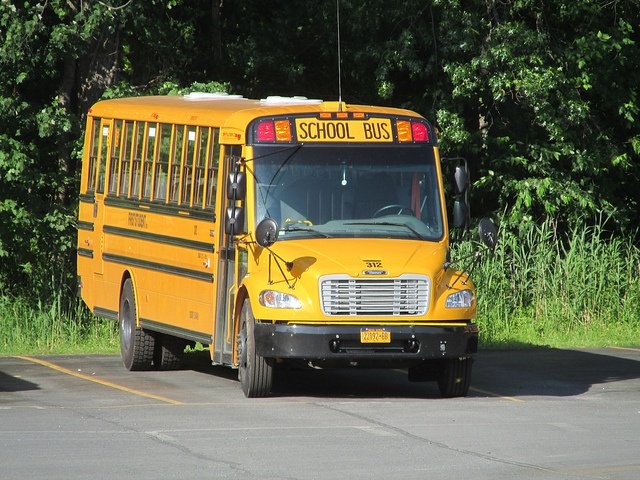Describe the objects in this image and their specific colors. I can see bus in black, orange, gray, and gold tones in this image. 